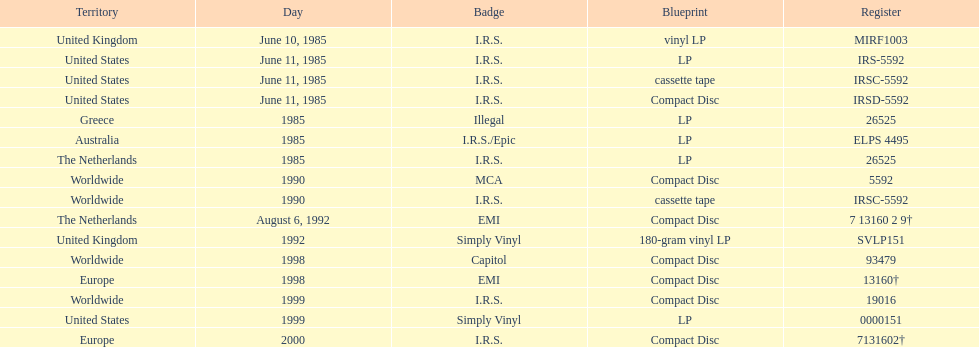How many occurrences was the album issued? 13. 